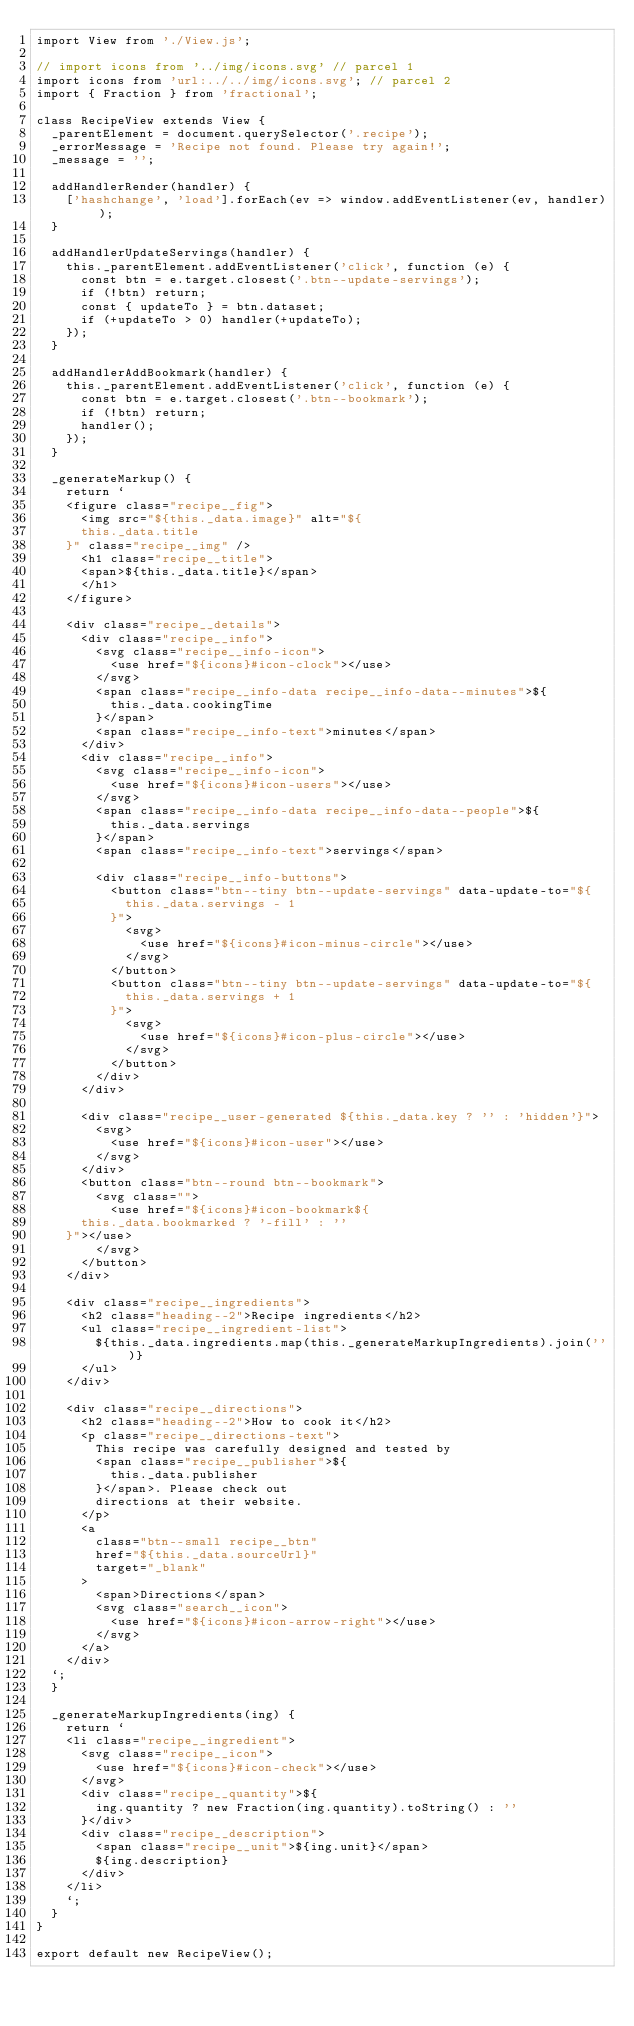<code> <loc_0><loc_0><loc_500><loc_500><_JavaScript_>import View from './View.js';

// import icons from '../img/icons.svg' // parcel 1
import icons from 'url:../../img/icons.svg'; // parcel 2
import { Fraction } from 'fractional';

class RecipeView extends View {
  _parentElement = document.querySelector('.recipe');
  _errorMessage = 'Recipe not found. Please try again!';
  _message = '';

  addHandlerRender(handler) {
    ['hashchange', 'load'].forEach(ev => window.addEventListener(ev, handler));
  }

  addHandlerUpdateServings(handler) {
    this._parentElement.addEventListener('click', function (e) {
      const btn = e.target.closest('.btn--update-servings');
      if (!btn) return;
      const { updateTo } = btn.dataset;
      if (+updateTo > 0) handler(+updateTo);
    });
  }

  addHandlerAddBookmark(handler) {
    this._parentElement.addEventListener('click', function (e) {
      const btn = e.target.closest('.btn--bookmark');
      if (!btn) return;
      handler();
    });
  }

  _generateMarkup() {
    return `
    <figure class="recipe__fig">
      <img src="${this._data.image}" alt="${
      this._data.title
    }" class="recipe__img" />
      <h1 class="recipe__title">
      <span>${this._data.title}</span>
      </h1>
    </figure>

    <div class="recipe__details">
      <div class="recipe__info">
        <svg class="recipe__info-icon">
          <use href="${icons}#icon-clock"></use>
        </svg>
        <span class="recipe__info-data recipe__info-data--minutes">${
          this._data.cookingTime
        }</span>
        <span class="recipe__info-text">minutes</span>
      </div>
      <div class="recipe__info">
        <svg class="recipe__info-icon">
          <use href="${icons}#icon-users"></use>
        </svg>
        <span class="recipe__info-data recipe__info-data--people">${
          this._data.servings
        }</span>
        <span class="recipe__info-text">servings</span>

        <div class="recipe__info-buttons">
          <button class="btn--tiny btn--update-servings" data-update-to="${
            this._data.servings - 1
          }">
            <svg>
              <use href="${icons}#icon-minus-circle"></use>
            </svg>
          </button>
          <button class="btn--tiny btn--update-servings" data-update-to="${
            this._data.servings + 1
          }">
            <svg>
              <use href="${icons}#icon-plus-circle"></use>
            </svg>
          </button>
        </div>
      </div>

      <div class="recipe__user-generated ${this._data.key ? '' : 'hidden'}">
        <svg>
          <use href="${icons}#icon-user"></use>
        </svg>
      </div>
      <button class="btn--round btn--bookmark">
        <svg class="">
          <use href="${icons}#icon-bookmark${
      this._data.bookmarked ? '-fill' : ''
    }"></use>
        </svg>
      </button>
    </div>

    <div class="recipe__ingredients">
      <h2 class="heading--2">Recipe ingredients</h2>
      <ul class="recipe__ingredient-list">
        ${this._data.ingredients.map(this._generateMarkupIngredients).join('')}
      </ul>
    </div>

    <div class="recipe__directions">
      <h2 class="heading--2">How to cook it</h2>
      <p class="recipe__directions-text">
        This recipe was carefully designed and tested by
        <span class="recipe__publisher">${
          this._data.publisher
        }</span>. Please check out
        directions at their website.
      </p>
      <a
        class="btn--small recipe__btn"
        href="${this._data.sourceUrl}"
        target="_blank"
      >
        <span>Directions</span>
        <svg class="search__icon">
          <use href="${icons}#icon-arrow-right"></use>
        </svg>
      </a>
    </div>
  `;
  }

  _generateMarkupIngredients(ing) {
    return `
    <li class="recipe__ingredient">
      <svg class="recipe__icon">
        <use href="${icons}#icon-check"></use>
      </svg>
      <div class="recipe__quantity">${
        ing.quantity ? new Fraction(ing.quantity).toString() : ''
      }</div>
      <div class="recipe__description">
        <span class="recipe__unit">${ing.unit}</span>
        ${ing.description}
      </div>
    </li>
    `;
  }
}

export default new RecipeView();
</code> 